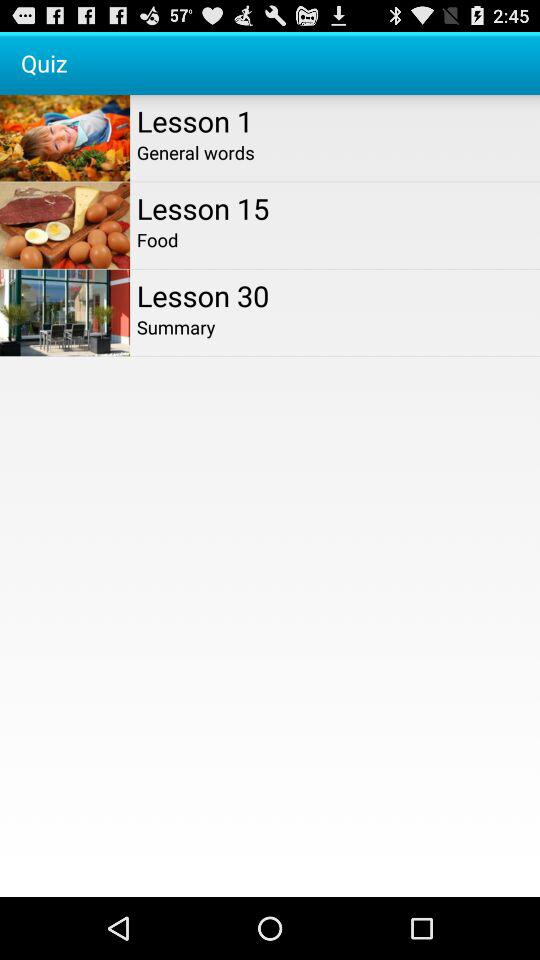On which topic is lesson 15? Lesson 15 is on "Food". 